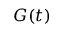Convert formula to latex. <formula><loc_0><loc_0><loc_500><loc_500>G ( t )</formula> 